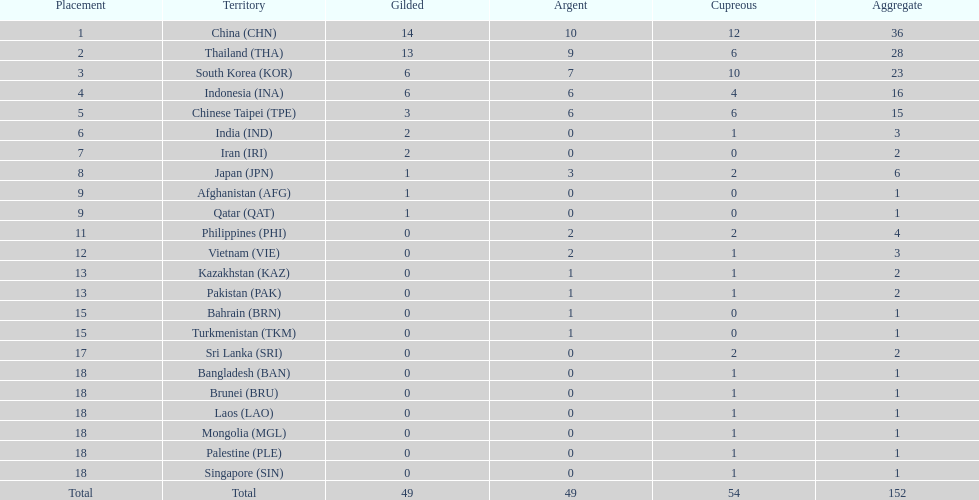How many nations won no silver medals at all? 11. 